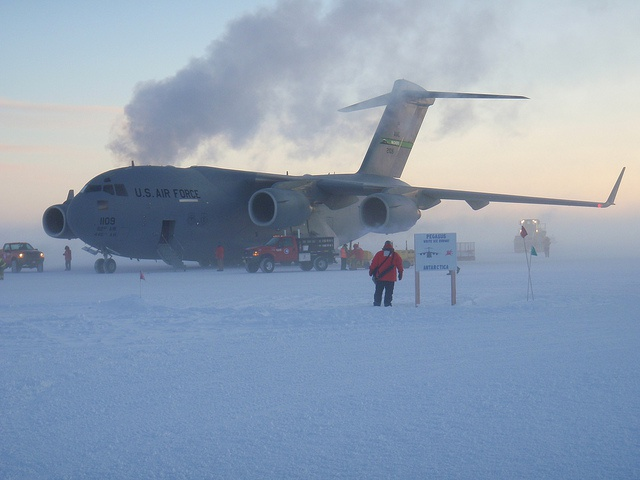Describe the objects in this image and their specific colors. I can see airplane in lightblue, gray, blue, and navy tones, truck in lightblue, gray, and blue tones, people in lightblue, purple, navy, darkblue, and gray tones, truck in lightblue and gray tones, and people in lightblue, gray, and darkgray tones in this image. 